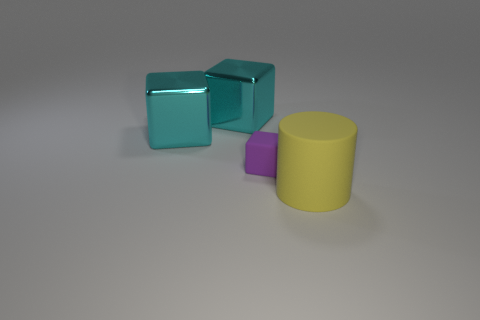What number of other objects are the same size as the yellow cylinder?
Offer a terse response. 2. How many small things are either yellow cylinders or matte blocks?
Your answer should be very brief. 1. There is a rubber cylinder; is it the same size as the matte object that is on the left side of the yellow object?
Give a very brief answer. No. How many other objects are there of the same shape as the tiny object?
Your response must be concise. 2. What shape is the purple object that is made of the same material as the yellow cylinder?
Your answer should be compact. Cube. Is there a purple rubber thing?
Your answer should be very brief. Yes. Are there fewer small rubber objects that are to the left of the tiny rubber object than big yellow rubber things behind the cylinder?
Keep it short and to the point. No. What shape is the object that is in front of the tiny purple object?
Give a very brief answer. Cylinder. Does the purple thing have the same material as the big cylinder?
Provide a short and direct response. Yes. Are there any other things that are the same material as the yellow object?
Keep it short and to the point. Yes. 